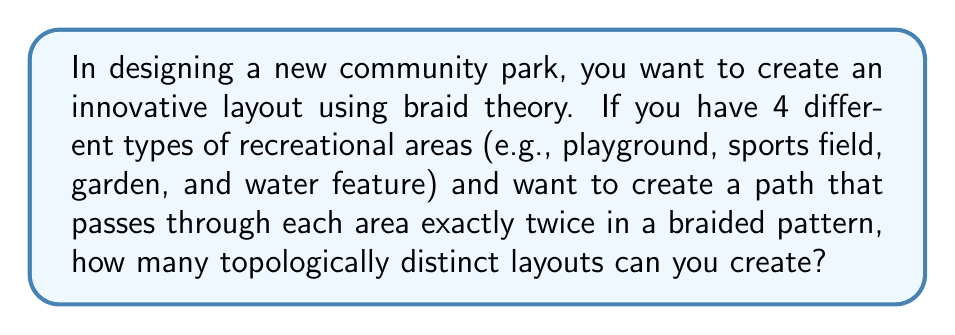What is the answer to this math problem? To solve this problem, we'll use concepts from braid theory:

1. First, we need to understand that this scenario corresponds to a 4-strand braid.

2. In braid theory, the number of topologically distinct n-strand braids with a fixed number of crossings is given by the nth Catalan number.

3. The nth Catalan number is defined by the formula:

   $$C_n = \frac{1}{n+1}\binom{2n}{n}$$

4. In our case, n = 4 (for 4 recreational areas).

5. Let's calculate:

   $$C_4 = \frac{1}{4+1}\binom{2(4)}{4} = \frac{1}{5}\binom{8}{4}$$

6. Expand the binomial coefficient:

   $$\binom{8}{4} = \frac{8!}{4!(8-4)!} = \frac{8!}{4!4!}$$

7. Calculate:

   $$\frac{8!}{4!4!} = \frac{8 \cdot 7 \cdot 6 \cdot 5}{4 \cdot 3 \cdot 2 \cdot 1} = 70$$

8. Therefore:

   $$C_4 = \frac{1}{5} \cdot 70 = 14$$

Thus, there are 14 topologically distinct layouts possible.
Answer: 14 